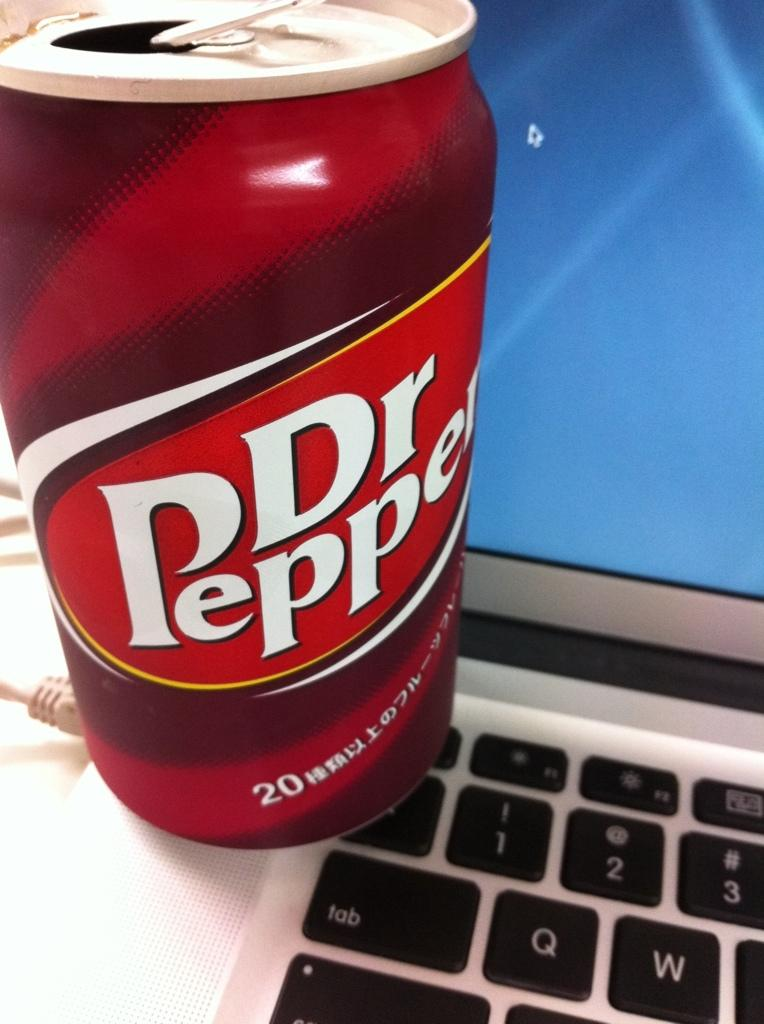<image>
Render a clear and concise summary of the photo. A can of the soda Dr Pepper sitting on a computer keyboard. 